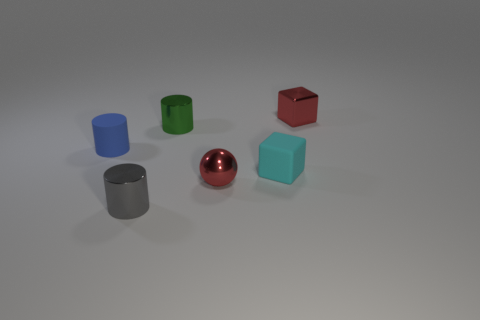Add 1 shiny cylinders. How many objects exist? 7 Subtract all blocks. How many objects are left? 4 Subtract all yellow matte blocks. Subtract all cylinders. How many objects are left? 3 Add 1 small blue objects. How many small blue objects are left? 2 Add 6 small cylinders. How many small cylinders exist? 9 Subtract 1 green cylinders. How many objects are left? 5 